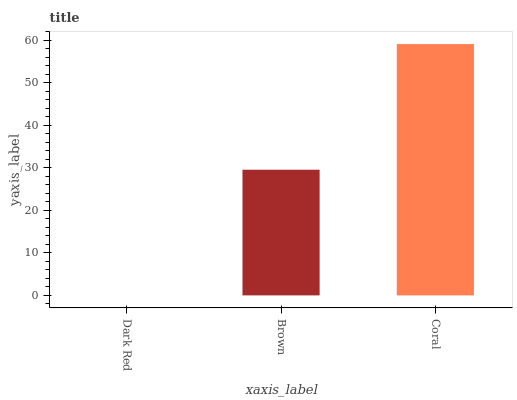Is Dark Red the minimum?
Answer yes or no. Yes. Is Coral the maximum?
Answer yes or no. Yes. Is Brown the minimum?
Answer yes or no. No. Is Brown the maximum?
Answer yes or no. No. Is Brown greater than Dark Red?
Answer yes or no. Yes. Is Dark Red less than Brown?
Answer yes or no. Yes. Is Dark Red greater than Brown?
Answer yes or no. No. Is Brown less than Dark Red?
Answer yes or no. No. Is Brown the high median?
Answer yes or no. Yes. Is Brown the low median?
Answer yes or no. Yes. Is Coral the high median?
Answer yes or no. No. Is Dark Red the low median?
Answer yes or no. No. 